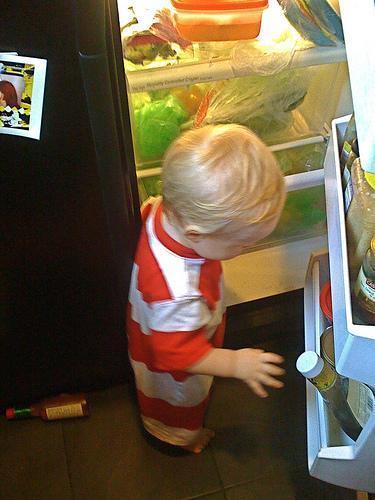How many people are in the photo?
Give a very brief answer. 1. 